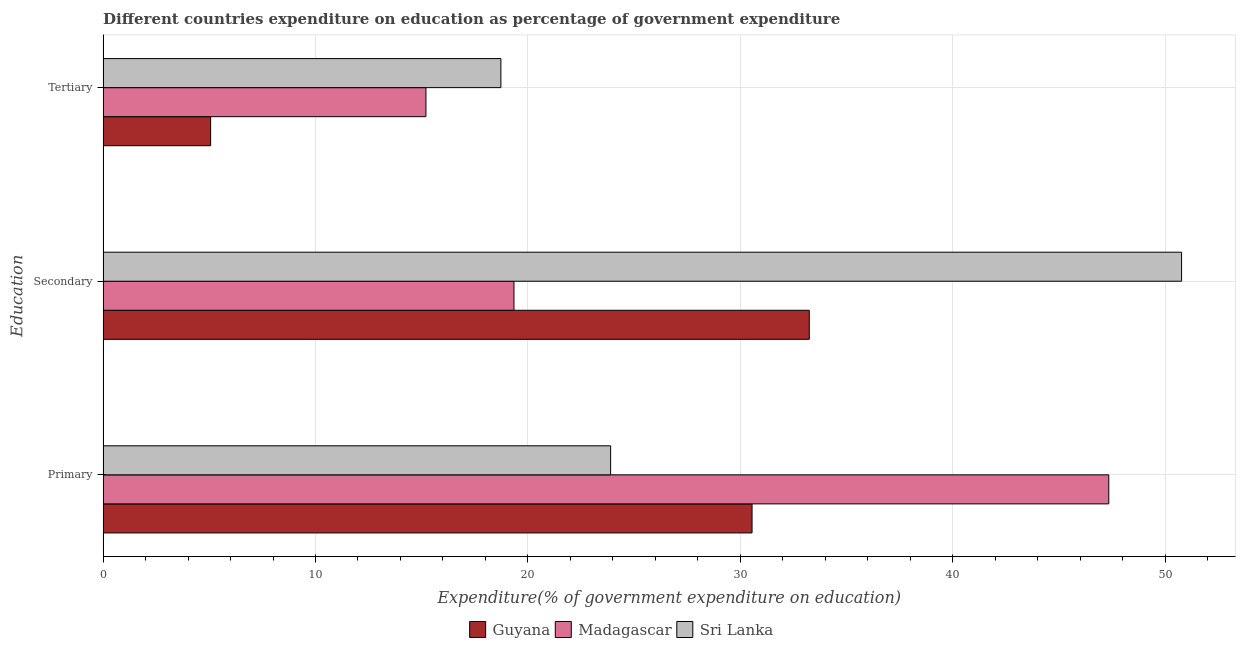How many groups of bars are there?
Offer a terse response. 3. Are the number of bars per tick equal to the number of legend labels?
Your response must be concise. Yes. How many bars are there on the 1st tick from the bottom?
Offer a very short reply. 3. What is the label of the 3rd group of bars from the top?
Your answer should be very brief. Primary. What is the expenditure on tertiary education in Sri Lanka?
Your response must be concise. 18.73. Across all countries, what is the maximum expenditure on tertiary education?
Your response must be concise. 18.73. Across all countries, what is the minimum expenditure on secondary education?
Your answer should be very brief. 19.34. In which country was the expenditure on secondary education maximum?
Ensure brevity in your answer.  Sri Lanka. In which country was the expenditure on tertiary education minimum?
Offer a terse response. Guyana. What is the total expenditure on tertiary education in the graph?
Ensure brevity in your answer.  38.99. What is the difference between the expenditure on secondary education in Guyana and that in Sri Lanka?
Your response must be concise. -17.53. What is the difference between the expenditure on secondary education in Madagascar and the expenditure on tertiary education in Guyana?
Offer a terse response. 14.28. What is the average expenditure on secondary education per country?
Your answer should be very brief. 34.46. What is the difference between the expenditure on primary education and expenditure on secondary education in Sri Lanka?
Your answer should be compact. -26.88. What is the ratio of the expenditure on secondary education in Madagascar to that in Guyana?
Your answer should be very brief. 0.58. Is the difference between the expenditure on tertiary education in Sri Lanka and Madagascar greater than the difference between the expenditure on secondary education in Sri Lanka and Madagascar?
Ensure brevity in your answer.  No. What is the difference between the highest and the second highest expenditure on tertiary education?
Your answer should be compact. 3.53. What is the difference between the highest and the lowest expenditure on primary education?
Your answer should be very brief. 23.46. In how many countries, is the expenditure on tertiary education greater than the average expenditure on tertiary education taken over all countries?
Give a very brief answer. 2. Is the sum of the expenditure on secondary education in Sri Lanka and Madagascar greater than the maximum expenditure on primary education across all countries?
Your response must be concise. Yes. What does the 3rd bar from the top in Primary represents?
Ensure brevity in your answer.  Guyana. What does the 1st bar from the bottom in Tertiary represents?
Your answer should be compact. Guyana. Are all the bars in the graph horizontal?
Your response must be concise. Yes. Does the graph contain grids?
Provide a succinct answer. Yes. Where does the legend appear in the graph?
Offer a terse response. Bottom center. How are the legend labels stacked?
Provide a short and direct response. Horizontal. What is the title of the graph?
Offer a very short reply. Different countries expenditure on education as percentage of government expenditure. Does "Sao Tome and Principe" appear as one of the legend labels in the graph?
Your answer should be compact. No. What is the label or title of the X-axis?
Offer a very short reply. Expenditure(% of government expenditure on education). What is the label or title of the Y-axis?
Give a very brief answer. Education. What is the Expenditure(% of government expenditure on education) in Guyana in Primary?
Give a very brief answer. 30.56. What is the Expenditure(% of government expenditure on education) of Madagascar in Primary?
Provide a succinct answer. 47.35. What is the Expenditure(% of government expenditure on education) of Sri Lanka in Primary?
Keep it short and to the point. 23.9. What is the Expenditure(% of government expenditure on education) of Guyana in Secondary?
Your answer should be compact. 33.25. What is the Expenditure(% of government expenditure on education) of Madagascar in Secondary?
Your response must be concise. 19.34. What is the Expenditure(% of government expenditure on education) in Sri Lanka in Secondary?
Provide a succinct answer. 50.78. What is the Expenditure(% of government expenditure on education) of Guyana in Tertiary?
Keep it short and to the point. 5.06. What is the Expenditure(% of government expenditure on education) of Madagascar in Tertiary?
Provide a succinct answer. 15.2. What is the Expenditure(% of government expenditure on education) of Sri Lanka in Tertiary?
Offer a terse response. 18.73. Across all Education, what is the maximum Expenditure(% of government expenditure on education) of Guyana?
Your response must be concise. 33.25. Across all Education, what is the maximum Expenditure(% of government expenditure on education) of Madagascar?
Offer a very short reply. 47.35. Across all Education, what is the maximum Expenditure(% of government expenditure on education) of Sri Lanka?
Offer a very short reply. 50.78. Across all Education, what is the minimum Expenditure(% of government expenditure on education) in Guyana?
Offer a terse response. 5.06. Across all Education, what is the minimum Expenditure(% of government expenditure on education) of Madagascar?
Give a very brief answer. 15.2. Across all Education, what is the minimum Expenditure(% of government expenditure on education) in Sri Lanka?
Offer a terse response. 18.73. What is the total Expenditure(% of government expenditure on education) of Guyana in the graph?
Provide a succinct answer. 68.87. What is the total Expenditure(% of government expenditure on education) in Madagascar in the graph?
Make the answer very short. 81.9. What is the total Expenditure(% of government expenditure on education) in Sri Lanka in the graph?
Provide a succinct answer. 93.4. What is the difference between the Expenditure(% of government expenditure on education) of Guyana in Primary and that in Secondary?
Make the answer very short. -2.7. What is the difference between the Expenditure(% of government expenditure on education) in Madagascar in Primary and that in Secondary?
Ensure brevity in your answer.  28.01. What is the difference between the Expenditure(% of government expenditure on education) in Sri Lanka in Primary and that in Secondary?
Keep it short and to the point. -26.88. What is the difference between the Expenditure(% of government expenditure on education) in Guyana in Primary and that in Tertiary?
Give a very brief answer. 25.49. What is the difference between the Expenditure(% of government expenditure on education) of Madagascar in Primary and that in Tertiary?
Ensure brevity in your answer.  32.15. What is the difference between the Expenditure(% of government expenditure on education) in Sri Lanka in Primary and that in Tertiary?
Offer a terse response. 5.17. What is the difference between the Expenditure(% of government expenditure on education) in Guyana in Secondary and that in Tertiary?
Keep it short and to the point. 28.19. What is the difference between the Expenditure(% of government expenditure on education) of Madagascar in Secondary and that in Tertiary?
Ensure brevity in your answer.  4.15. What is the difference between the Expenditure(% of government expenditure on education) in Sri Lanka in Secondary and that in Tertiary?
Ensure brevity in your answer.  32.05. What is the difference between the Expenditure(% of government expenditure on education) of Guyana in Primary and the Expenditure(% of government expenditure on education) of Madagascar in Secondary?
Your answer should be very brief. 11.21. What is the difference between the Expenditure(% of government expenditure on education) of Guyana in Primary and the Expenditure(% of government expenditure on education) of Sri Lanka in Secondary?
Your answer should be compact. -20.22. What is the difference between the Expenditure(% of government expenditure on education) of Madagascar in Primary and the Expenditure(% of government expenditure on education) of Sri Lanka in Secondary?
Offer a terse response. -3.43. What is the difference between the Expenditure(% of government expenditure on education) of Guyana in Primary and the Expenditure(% of government expenditure on education) of Madagascar in Tertiary?
Offer a very short reply. 15.36. What is the difference between the Expenditure(% of government expenditure on education) in Guyana in Primary and the Expenditure(% of government expenditure on education) in Sri Lanka in Tertiary?
Offer a very short reply. 11.83. What is the difference between the Expenditure(% of government expenditure on education) of Madagascar in Primary and the Expenditure(% of government expenditure on education) of Sri Lanka in Tertiary?
Your answer should be compact. 28.62. What is the difference between the Expenditure(% of government expenditure on education) in Guyana in Secondary and the Expenditure(% of government expenditure on education) in Madagascar in Tertiary?
Ensure brevity in your answer.  18.05. What is the difference between the Expenditure(% of government expenditure on education) of Guyana in Secondary and the Expenditure(% of government expenditure on education) of Sri Lanka in Tertiary?
Keep it short and to the point. 14.52. What is the difference between the Expenditure(% of government expenditure on education) in Madagascar in Secondary and the Expenditure(% of government expenditure on education) in Sri Lanka in Tertiary?
Provide a succinct answer. 0.62. What is the average Expenditure(% of government expenditure on education) in Guyana per Education?
Offer a very short reply. 22.96. What is the average Expenditure(% of government expenditure on education) of Madagascar per Education?
Ensure brevity in your answer.  27.3. What is the average Expenditure(% of government expenditure on education) of Sri Lanka per Education?
Offer a very short reply. 31.13. What is the difference between the Expenditure(% of government expenditure on education) of Guyana and Expenditure(% of government expenditure on education) of Madagascar in Primary?
Provide a succinct answer. -16.8. What is the difference between the Expenditure(% of government expenditure on education) of Guyana and Expenditure(% of government expenditure on education) of Sri Lanka in Primary?
Your response must be concise. 6.66. What is the difference between the Expenditure(% of government expenditure on education) in Madagascar and Expenditure(% of government expenditure on education) in Sri Lanka in Primary?
Your answer should be very brief. 23.46. What is the difference between the Expenditure(% of government expenditure on education) in Guyana and Expenditure(% of government expenditure on education) in Madagascar in Secondary?
Give a very brief answer. 13.91. What is the difference between the Expenditure(% of government expenditure on education) of Guyana and Expenditure(% of government expenditure on education) of Sri Lanka in Secondary?
Offer a terse response. -17.53. What is the difference between the Expenditure(% of government expenditure on education) of Madagascar and Expenditure(% of government expenditure on education) of Sri Lanka in Secondary?
Offer a terse response. -31.43. What is the difference between the Expenditure(% of government expenditure on education) of Guyana and Expenditure(% of government expenditure on education) of Madagascar in Tertiary?
Provide a short and direct response. -10.14. What is the difference between the Expenditure(% of government expenditure on education) in Guyana and Expenditure(% of government expenditure on education) in Sri Lanka in Tertiary?
Your answer should be compact. -13.67. What is the difference between the Expenditure(% of government expenditure on education) of Madagascar and Expenditure(% of government expenditure on education) of Sri Lanka in Tertiary?
Provide a succinct answer. -3.53. What is the ratio of the Expenditure(% of government expenditure on education) of Guyana in Primary to that in Secondary?
Make the answer very short. 0.92. What is the ratio of the Expenditure(% of government expenditure on education) in Madagascar in Primary to that in Secondary?
Provide a succinct answer. 2.45. What is the ratio of the Expenditure(% of government expenditure on education) of Sri Lanka in Primary to that in Secondary?
Give a very brief answer. 0.47. What is the ratio of the Expenditure(% of government expenditure on education) in Guyana in Primary to that in Tertiary?
Your answer should be very brief. 6.04. What is the ratio of the Expenditure(% of government expenditure on education) of Madagascar in Primary to that in Tertiary?
Give a very brief answer. 3.12. What is the ratio of the Expenditure(% of government expenditure on education) in Sri Lanka in Primary to that in Tertiary?
Your answer should be compact. 1.28. What is the ratio of the Expenditure(% of government expenditure on education) of Guyana in Secondary to that in Tertiary?
Give a very brief answer. 6.57. What is the ratio of the Expenditure(% of government expenditure on education) in Madagascar in Secondary to that in Tertiary?
Ensure brevity in your answer.  1.27. What is the ratio of the Expenditure(% of government expenditure on education) in Sri Lanka in Secondary to that in Tertiary?
Provide a short and direct response. 2.71. What is the difference between the highest and the second highest Expenditure(% of government expenditure on education) of Guyana?
Make the answer very short. 2.7. What is the difference between the highest and the second highest Expenditure(% of government expenditure on education) of Madagascar?
Provide a succinct answer. 28.01. What is the difference between the highest and the second highest Expenditure(% of government expenditure on education) in Sri Lanka?
Your answer should be compact. 26.88. What is the difference between the highest and the lowest Expenditure(% of government expenditure on education) in Guyana?
Offer a very short reply. 28.19. What is the difference between the highest and the lowest Expenditure(% of government expenditure on education) of Madagascar?
Your answer should be compact. 32.15. What is the difference between the highest and the lowest Expenditure(% of government expenditure on education) of Sri Lanka?
Your answer should be compact. 32.05. 